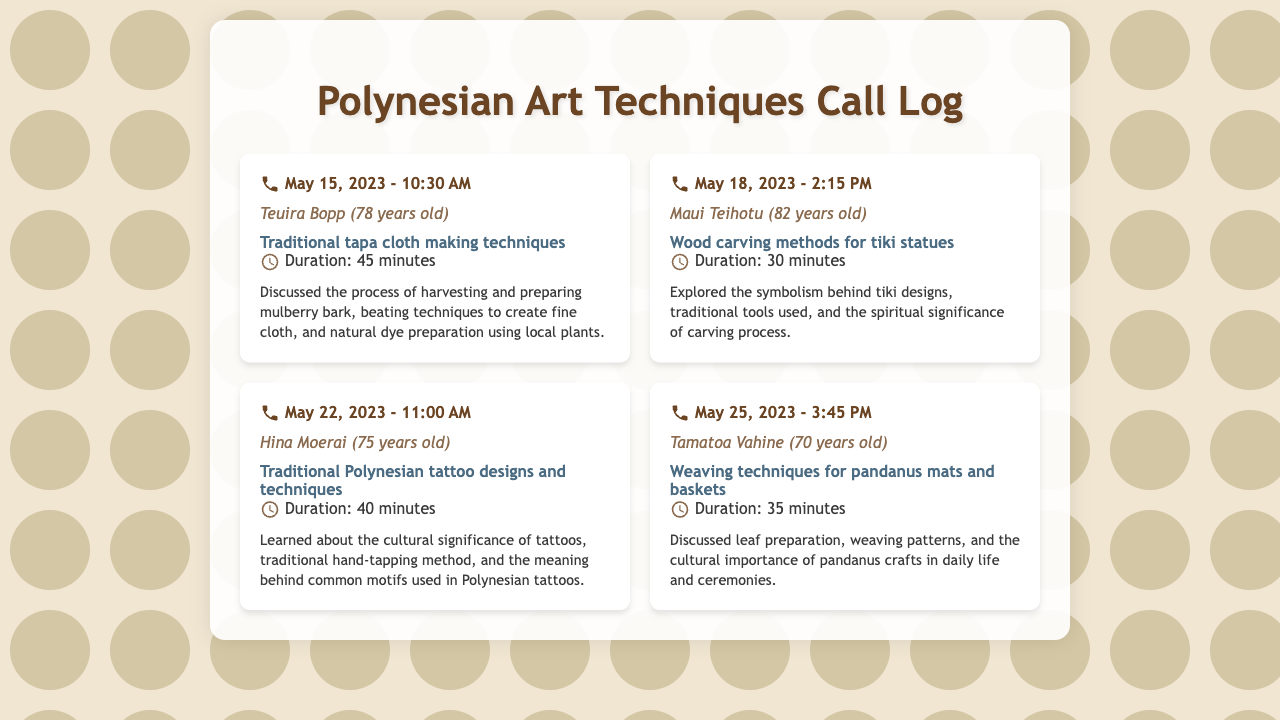What is the date of the call with Teuira Bopp? The date of the call with Teuira Bopp is found in the first call entry.
Answer: May 15, 2023 How long was the conversation with Maui Teihotu? The duration of the call with Maui Teihotu is mentioned in the call entry.
Answer: 30 minutes What is the main topic discussed with Hina Moerai? The main topic for Hina Moerai is specified in the call entry.
Answer: Traditional Polynesian tattoo designs and techniques Who is 70 years old among the callers? The age of Tamatoa Vahine is stated in the call entry.
Answer: Tamatoa Vahine What cultural significance did the conversation on May 25, 2023, cover? The cultural importance of pandanus crafts is noted in the notes part of the call entry.
Answer: Daily life and ceremonies What technique was discussed in the call on May 22, 2023? The technique discussed with Hina Moerai is included in the call notes.
Answer: Traditional hand-tapping method Which elder discussed weaving techniques? The elder who talked about weaving techniques is listed in the call log.
Answer: Tamatoa Vahine What symbolism was explored during the call with Maui Teihotu? The symbolism behind tiki designs is mentioned in the related call entry.
Answer: Tiki designs 